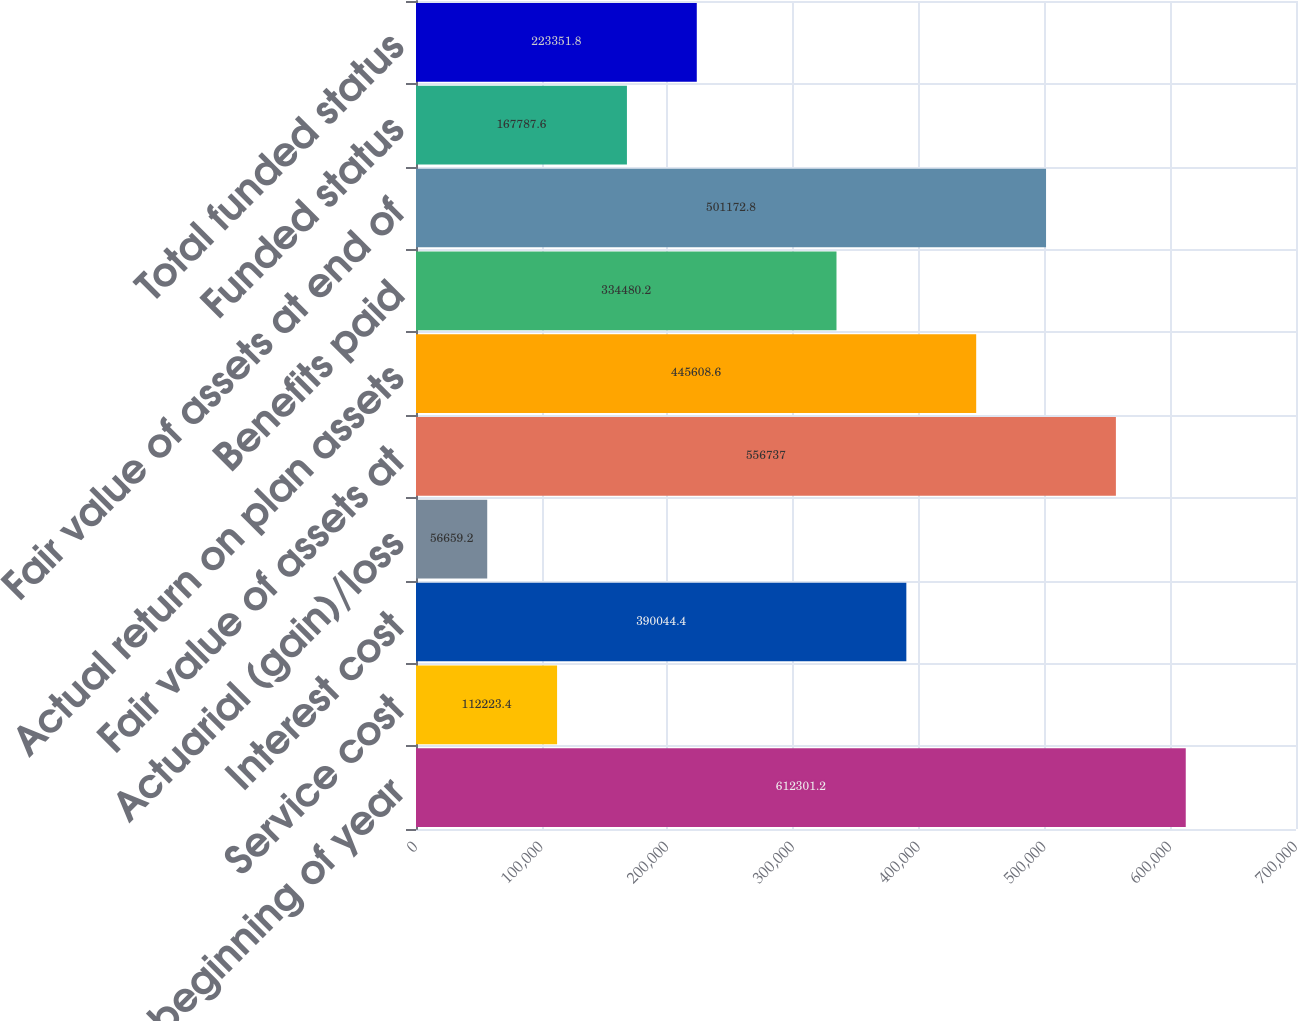Convert chart to OTSL. <chart><loc_0><loc_0><loc_500><loc_500><bar_chart><fcel>Balance at beginning of year<fcel>Service cost<fcel>Interest cost<fcel>Actuarial (gain)/loss<fcel>Fair value of assets at<fcel>Actual return on plan assets<fcel>Benefits paid<fcel>Fair value of assets at end of<fcel>Funded status<fcel>Total funded status<nl><fcel>612301<fcel>112223<fcel>390044<fcel>56659.2<fcel>556737<fcel>445609<fcel>334480<fcel>501173<fcel>167788<fcel>223352<nl></chart> 